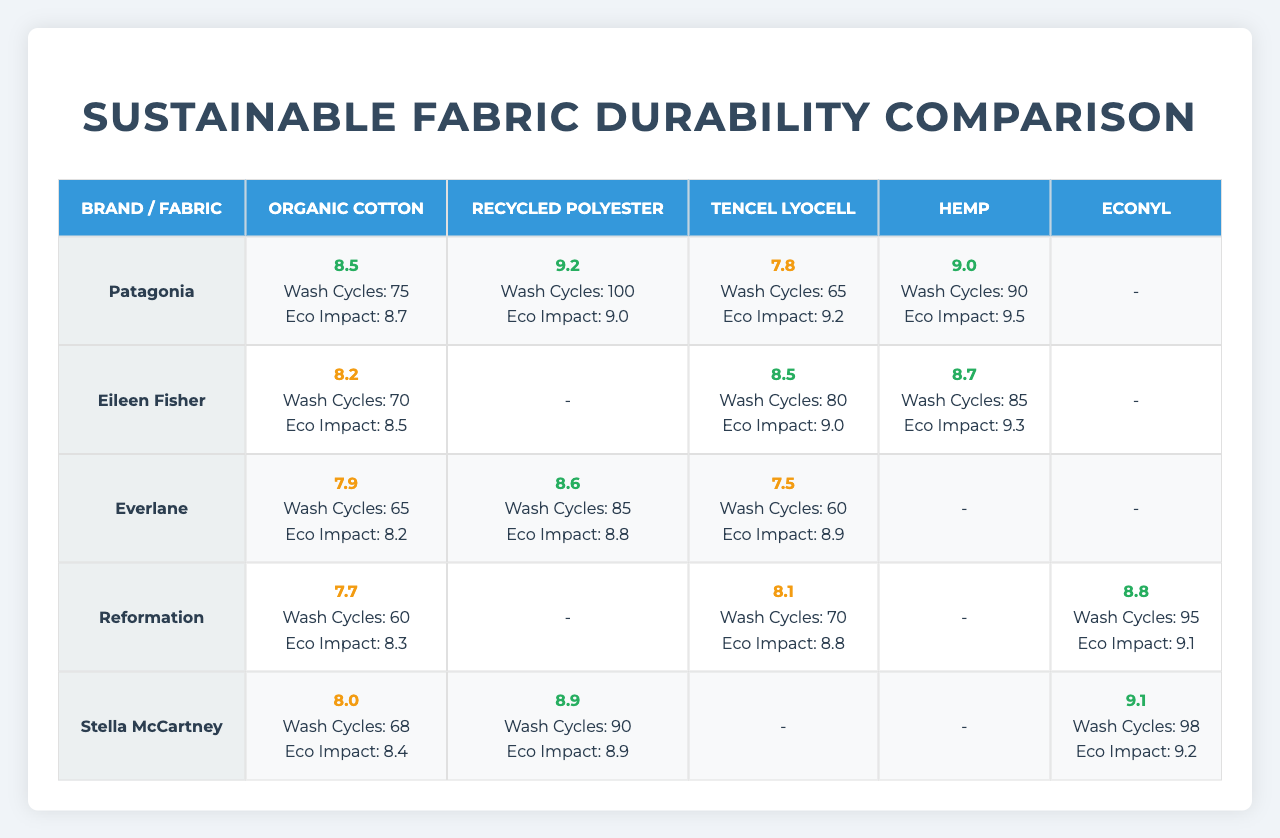What brand has the highest durability score for Tencel Lyocell? Looking at the durability scores for Tencel Lyocell, Patagonia has a score of 7.8, Eileen Fisher has 8.5, Everlane has 7.5, Reformation has 8.1, and Stella McCartney does not have a score for this fabric. The highest score is from Eileen Fisher at 8.5.
Answer: Eileen Fisher How many wash cycles can you expect from Reformation's Econyl fabric before degradation? The table indicates that Reformation's Econyl can withstand 95 wash cycles before degradation.
Answer: 95 Which brand's Organic Cotton has the lowest environmental impact score? Evaluating the environmental impact scores for Organic Cotton, Patagonia has 8.7, Eileen Fisher has 8.5, Everlane has 8.2, Reformation has 8.3, and Stella McCartney has 8.4. The lowest score is from Everlane at 8.2.
Answer: Everlane What is the average durability score across all fabrics for Stella McCartney? The durability scores for Stella McCartney are as follows: Organic Cotton (8.0), Recycled Polyester (8.9), and Econyl (9.1). Calculating the average: (8.0 + 8.9 + 9.1) / 3 = 8.67.
Answer: 8.67 Is the durability score for Organic Cotton from Patagonia higher than the score for Tencel Lyocell from Everlane? Patagonia's Organic Cotton has a score of 8.5 which is higher than Everlane's Tencel Lyocell score of 7.5. Therefore, the statement is true.
Answer: Yes Which fabric has the highest wash cycles before degradation in the brand Eileen Fisher? Eileen Fisher's wash cycles before degradation for Organic Cotton is 70, for Tencel Lyocell is 80, and for Hemp is 85. The fabric with the highest wash cycles is Hemp at 85.
Answer: Hemp What is the difference in durability scores between the best and worst performing fabrics under Everlane? Everlane's scores: Organic Cotton (7.9), Recycled Polyester (8.6), and Tencel Lyocell (7.5). The best score is 8.6 for Recycled Polyester and the worst is 7.5 for Tencel Lyocell, resulting in a difference of 8.6 - 7.5 = 1.1.
Answer: 1.1 Which brand among the listed has the highest overall durability score? To find the highest overall durability score, compare the highest scores for each brand. Patagonia's highest score is 9.2, Eileen Fisher has 8.7, Everlane has 8.6, Reformation has 8.8, and Stella McCartney has 9.1. The highest score is 9.2 from Patagonia.
Answer: Patagonia Does Reformation produce a fabric that has higher durability than Eileen Fisher's best fabric? Reformation's best score is 8.8 (Econyl), while Eileen Fisher's best is 8.7 (Tencel Lyocell). Since 8.8 is higher than 8.7, the statement is true.
Answer: Yes 